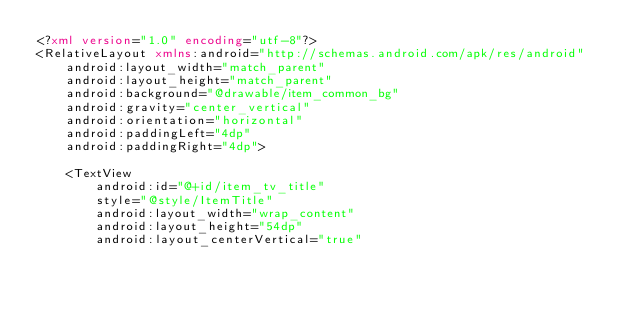Convert code to text. <code><loc_0><loc_0><loc_500><loc_500><_XML_><?xml version="1.0" encoding="utf-8"?>
<RelativeLayout xmlns:android="http://schemas.android.com/apk/res/android"
    android:layout_width="match_parent"
    android:layout_height="match_parent"
    android:background="@drawable/item_common_bg"
    android:gravity="center_vertical"
    android:orientation="horizontal"
    android:paddingLeft="4dp"
    android:paddingRight="4dp">

    <TextView
        android:id="@+id/item_tv_title"
        style="@style/ItemTitle"
        android:layout_width="wrap_content"
        android:layout_height="54dp"
        android:layout_centerVertical="true"</code> 